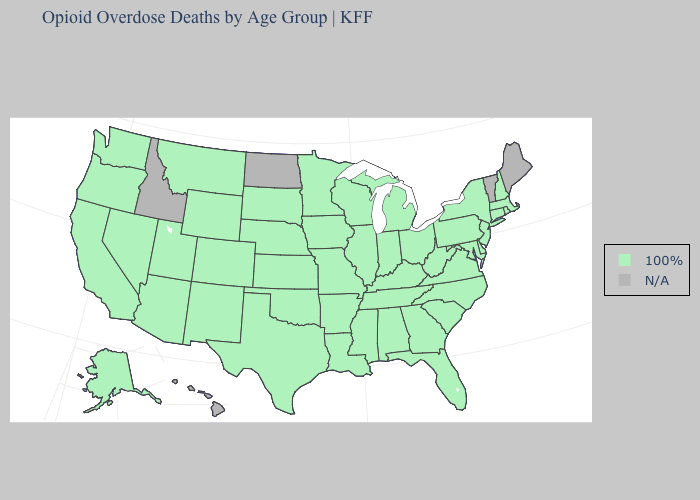How many symbols are there in the legend?
Concise answer only. 2. Name the states that have a value in the range 100%?
Be succinct. Alabama, Alaska, Arizona, Arkansas, California, Colorado, Connecticut, Delaware, Florida, Georgia, Illinois, Indiana, Iowa, Kansas, Kentucky, Louisiana, Maryland, Massachusetts, Michigan, Minnesota, Mississippi, Missouri, Montana, Nebraska, Nevada, New Hampshire, New Jersey, New Mexico, New York, North Carolina, Ohio, Oklahoma, Oregon, Pennsylvania, Rhode Island, South Carolina, South Dakota, Tennessee, Texas, Utah, Virginia, Washington, West Virginia, Wisconsin, Wyoming. Name the states that have a value in the range N/A?
Quick response, please. Hawaii, Idaho, Maine, North Dakota, Vermont. Which states have the highest value in the USA?
Write a very short answer. Alabama, Alaska, Arizona, Arkansas, California, Colorado, Connecticut, Delaware, Florida, Georgia, Illinois, Indiana, Iowa, Kansas, Kentucky, Louisiana, Maryland, Massachusetts, Michigan, Minnesota, Mississippi, Missouri, Montana, Nebraska, Nevada, New Hampshire, New Jersey, New Mexico, New York, North Carolina, Ohio, Oklahoma, Oregon, Pennsylvania, Rhode Island, South Carolina, South Dakota, Tennessee, Texas, Utah, Virginia, Washington, West Virginia, Wisconsin, Wyoming. Name the states that have a value in the range N/A?
Concise answer only. Hawaii, Idaho, Maine, North Dakota, Vermont. Name the states that have a value in the range N/A?
Write a very short answer. Hawaii, Idaho, Maine, North Dakota, Vermont. Does the first symbol in the legend represent the smallest category?
Keep it brief. No. What is the value of Alabama?
Concise answer only. 100%. Name the states that have a value in the range 100%?
Give a very brief answer. Alabama, Alaska, Arizona, Arkansas, California, Colorado, Connecticut, Delaware, Florida, Georgia, Illinois, Indiana, Iowa, Kansas, Kentucky, Louisiana, Maryland, Massachusetts, Michigan, Minnesota, Mississippi, Missouri, Montana, Nebraska, Nevada, New Hampshire, New Jersey, New Mexico, New York, North Carolina, Ohio, Oklahoma, Oregon, Pennsylvania, Rhode Island, South Carolina, South Dakota, Tennessee, Texas, Utah, Virginia, Washington, West Virginia, Wisconsin, Wyoming. Which states have the lowest value in the USA?
Keep it brief. Alabama, Alaska, Arizona, Arkansas, California, Colorado, Connecticut, Delaware, Florida, Georgia, Illinois, Indiana, Iowa, Kansas, Kentucky, Louisiana, Maryland, Massachusetts, Michigan, Minnesota, Mississippi, Missouri, Montana, Nebraska, Nevada, New Hampshire, New Jersey, New Mexico, New York, North Carolina, Ohio, Oklahoma, Oregon, Pennsylvania, Rhode Island, South Carolina, South Dakota, Tennessee, Texas, Utah, Virginia, Washington, West Virginia, Wisconsin, Wyoming. Does the first symbol in the legend represent the smallest category?
Concise answer only. No. 